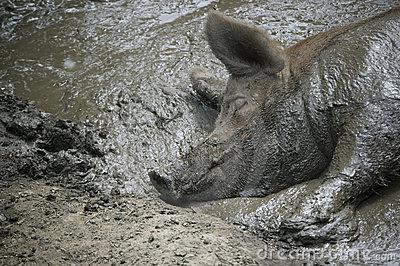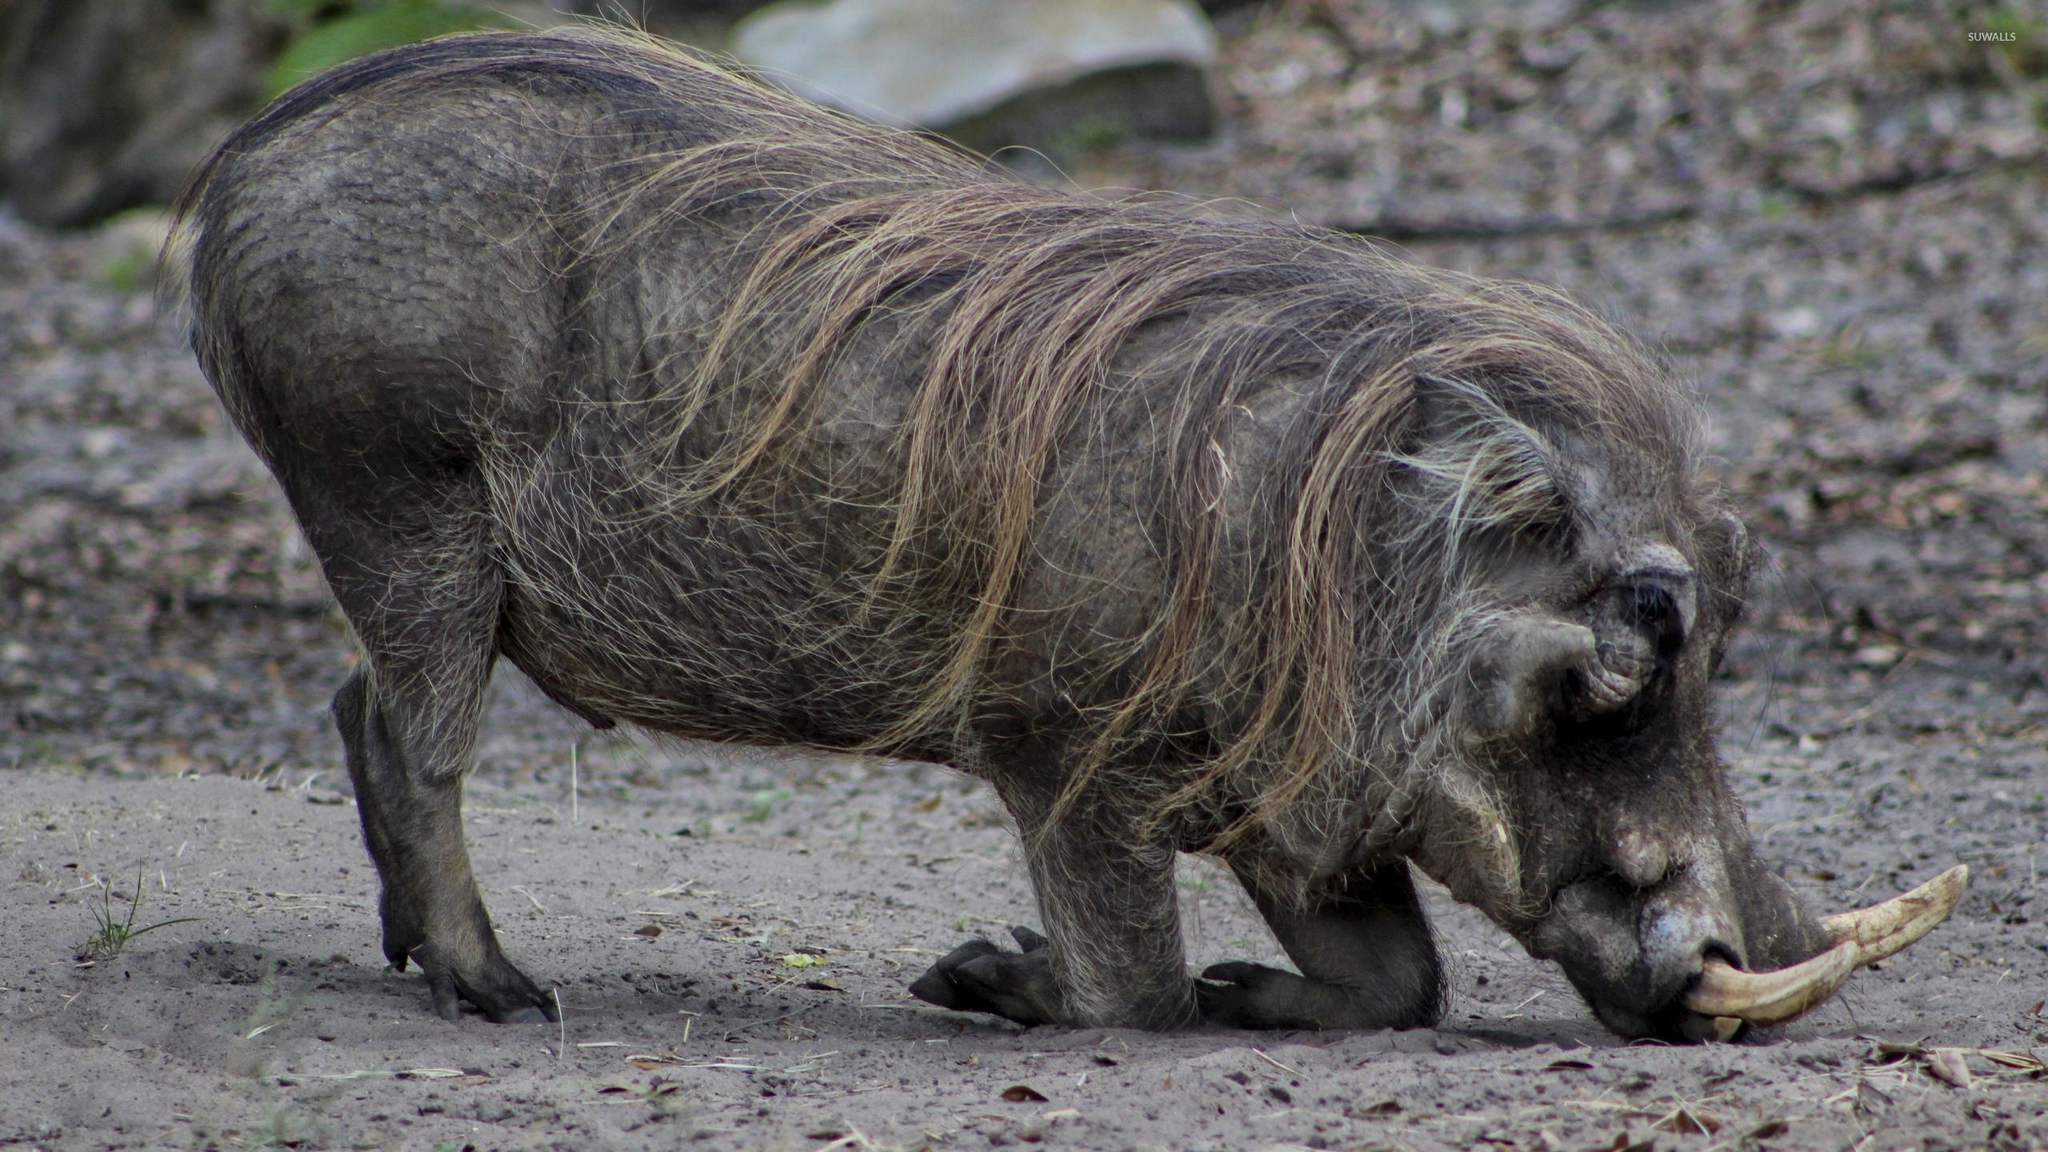The first image is the image on the left, the second image is the image on the right. Analyze the images presented: Is the assertion "There are at least two animals in the image on the left." valid? Answer yes or no. No. 